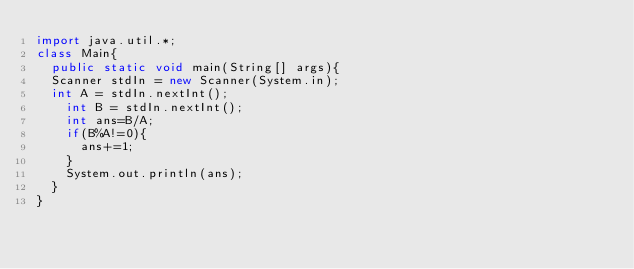<code> <loc_0><loc_0><loc_500><loc_500><_Java_>import java.util.*;
class Main{
  public static void main(String[] args){
	Scanner stdIn = new Scanner(System.in);
	int A = stdIn.nextInt();
    int B = stdIn.nextInt();
    int ans=B/A;
    if(B%A!=0){
      ans+=1;
    }
    System.out.println(ans);
  }
}</code> 